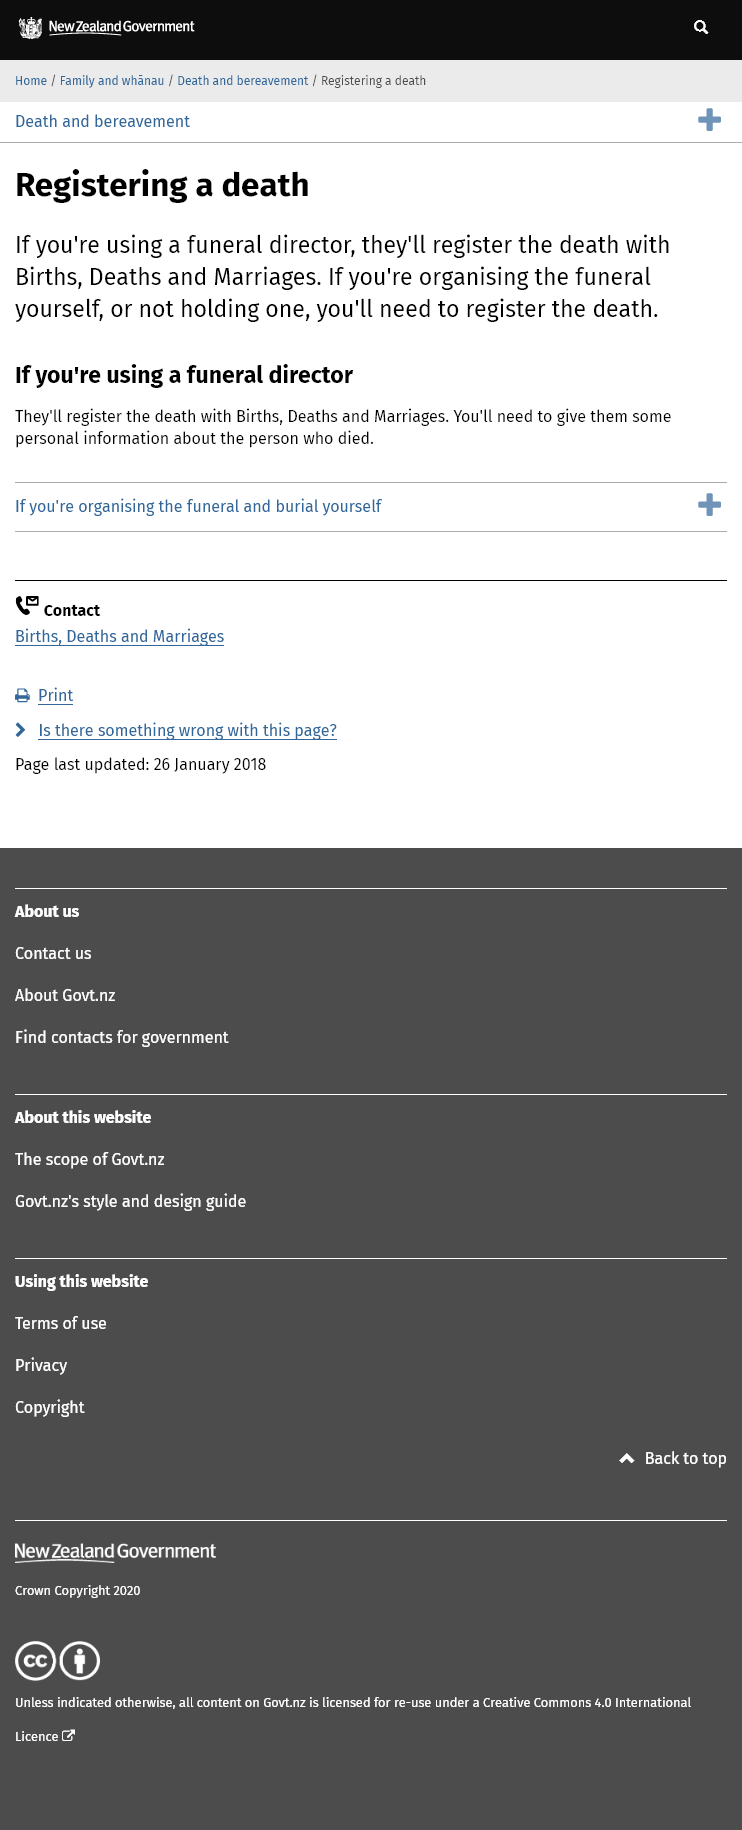List a handful of essential elements in this visual. Funeral directors register deaths with the relevant authorities, specifically Births, Deaths and Marriages. If a funeral director is involved, the funeral director will register the death. It is required to register a death if one does not hold a funeral, and you must register the death if you are the person responsible for doing so. 